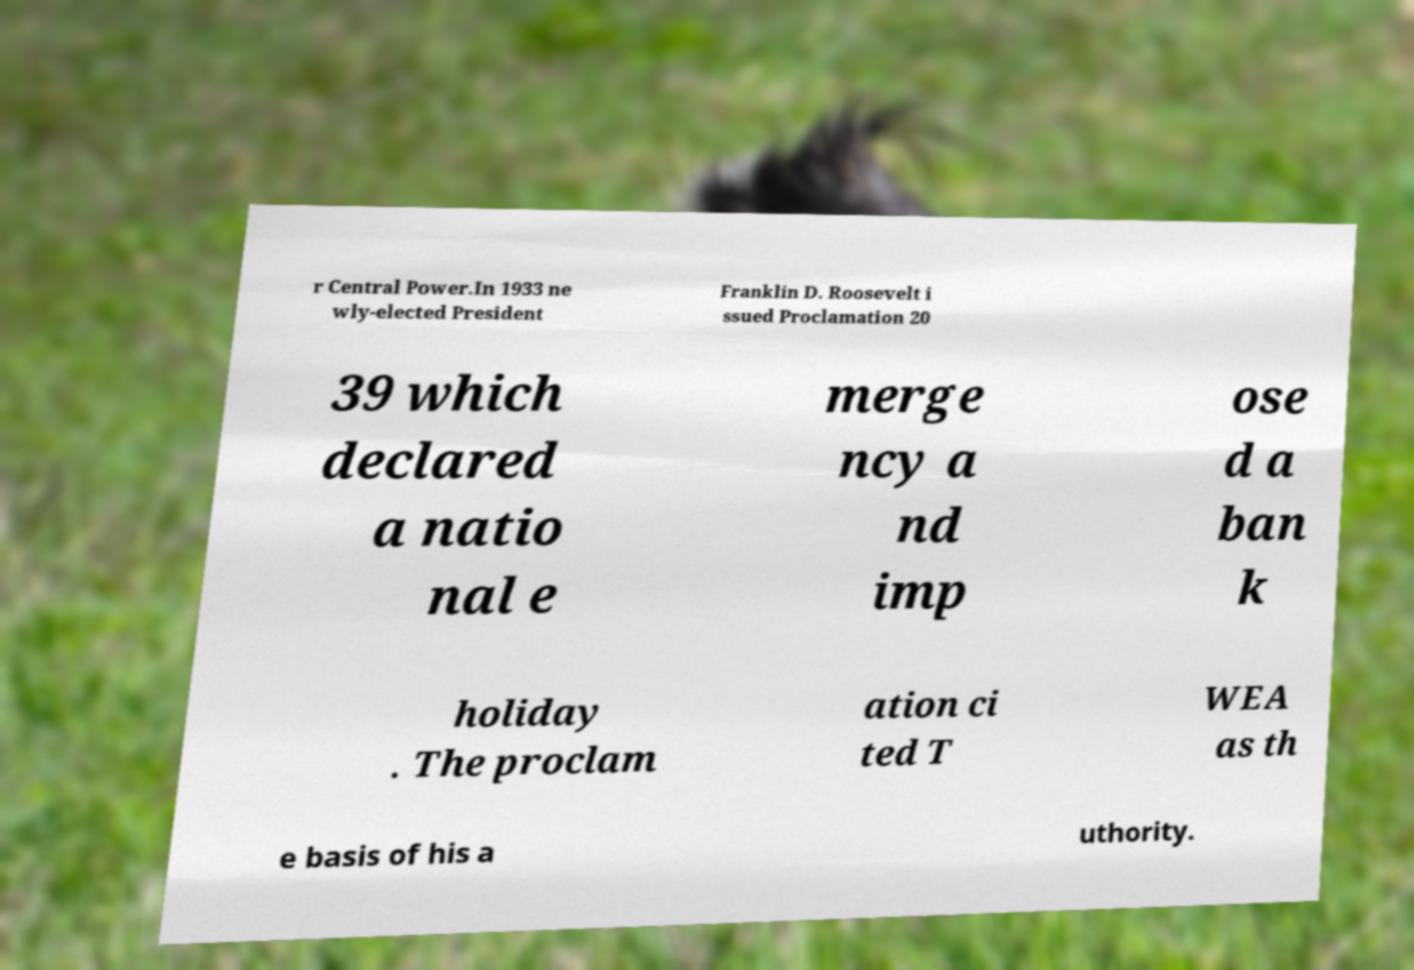Please read and relay the text visible in this image. What does it say? r Central Power.In 1933 ne wly-elected President Franklin D. Roosevelt i ssued Proclamation 20 39 which declared a natio nal e merge ncy a nd imp ose d a ban k holiday . The proclam ation ci ted T WEA as th e basis of his a uthority. 